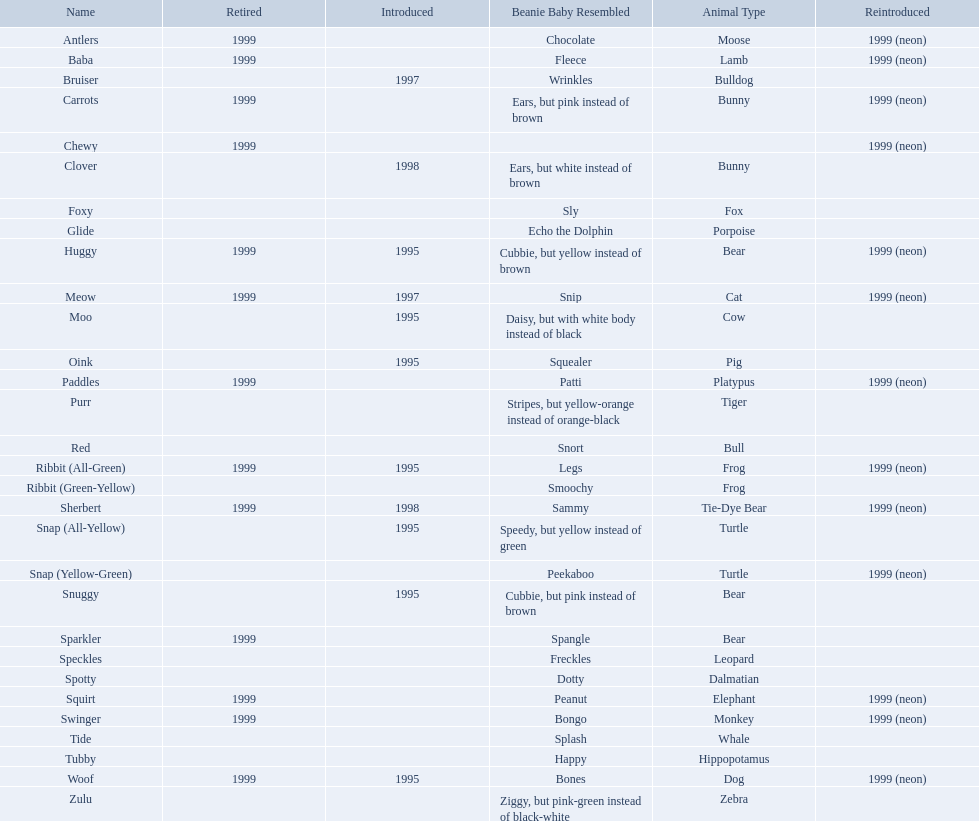What are the names listed? Antlers, Baba, Bruiser, Carrots, Chewy, Clover, Foxy, Glide, Huggy, Meow, Moo, Oink, Paddles, Purr, Red, Ribbit (All-Green), Ribbit (Green-Yellow), Sherbert, Snap (All-Yellow), Snap (Yellow-Green), Snuggy, Sparkler, Speckles, Spotty, Squirt, Swinger, Tide, Tubby, Woof, Zulu. Of these, which is the only pet without an animal type listed? Chewy. Parse the full table. {'header': ['Name', 'Retired', 'Introduced', 'Beanie Baby Resembled', 'Animal Type', 'Reintroduced'], 'rows': [['Antlers', '1999', '', 'Chocolate', 'Moose', '1999 (neon)'], ['Baba', '1999', '', 'Fleece', 'Lamb', '1999 (neon)'], ['Bruiser', '', '1997', 'Wrinkles', 'Bulldog', ''], ['Carrots', '1999', '', 'Ears, but pink instead of brown', 'Bunny', '1999 (neon)'], ['Chewy', '1999', '', '', '', '1999 (neon)'], ['Clover', '', '1998', 'Ears, but white instead of brown', 'Bunny', ''], ['Foxy', '', '', 'Sly', 'Fox', ''], ['Glide', '', '', 'Echo the Dolphin', 'Porpoise', ''], ['Huggy', '1999', '1995', 'Cubbie, but yellow instead of brown', 'Bear', '1999 (neon)'], ['Meow', '1999', '1997', 'Snip', 'Cat', '1999 (neon)'], ['Moo', '', '1995', 'Daisy, but with white body instead of black', 'Cow', ''], ['Oink', '', '1995', 'Squealer', 'Pig', ''], ['Paddles', '1999', '', 'Patti', 'Platypus', '1999 (neon)'], ['Purr', '', '', 'Stripes, but yellow-orange instead of orange-black', 'Tiger', ''], ['Red', '', '', 'Snort', 'Bull', ''], ['Ribbit (All-Green)', '1999', '1995', 'Legs', 'Frog', '1999 (neon)'], ['Ribbit (Green-Yellow)', '', '', 'Smoochy', 'Frog', ''], ['Sherbert', '1999', '1998', 'Sammy', 'Tie-Dye Bear', '1999 (neon)'], ['Snap (All-Yellow)', '', '1995', 'Speedy, but yellow instead of green', 'Turtle', ''], ['Snap (Yellow-Green)', '', '', 'Peekaboo', 'Turtle', '1999 (neon)'], ['Snuggy', '', '1995', 'Cubbie, but pink instead of brown', 'Bear', ''], ['Sparkler', '1999', '', 'Spangle', 'Bear', ''], ['Speckles', '', '', 'Freckles', 'Leopard', ''], ['Spotty', '', '', 'Dotty', 'Dalmatian', ''], ['Squirt', '1999', '', 'Peanut', 'Elephant', '1999 (neon)'], ['Swinger', '1999', '', 'Bongo', 'Monkey', '1999 (neon)'], ['Tide', '', '', 'Splash', 'Whale', ''], ['Tubby', '', '', 'Happy', 'Hippopotamus', ''], ['Woof', '1999', '1995', 'Bones', 'Dog', '1999 (neon)'], ['Zulu', '', '', 'Ziggy, but pink-green instead of black-white', 'Zebra', '']]} Which of the listed pillow pals lack information in at least 3 categories? Chewy, Foxy, Glide, Purr, Red, Ribbit (Green-Yellow), Speckles, Spotty, Tide, Tubby, Zulu. Of those, which one lacks information in the animal type category? Chewy. 